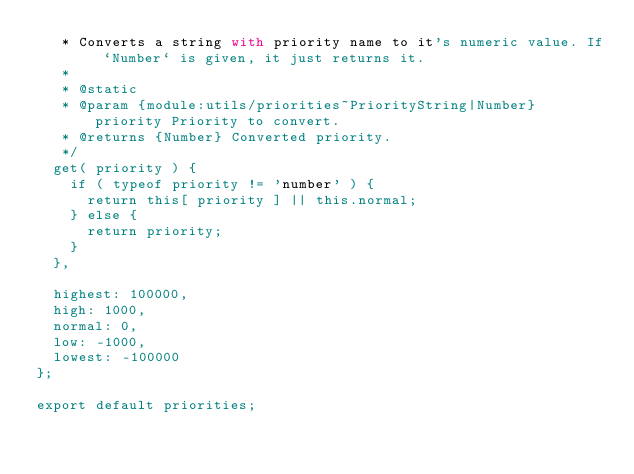Convert code to text. <code><loc_0><loc_0><loc_500><loc_500><_JavaScript_>	 * Converts a string with priority name to it's numeric value. If `Number` is given, it just returns it.
	 *
	 * @static
	 * @param {module:utils/priorities~PriorityString|Number} priority Priority to convert.
	 * @returns {Number} Converted priority.
	 */
	get( priority ) {
		if ( typeof priority != 'number' ) {
			return this[ priority ] || this.normal;
		} else {
			return priority;
		}
	},

	highest: 100000,
	high: 1000,
	normal: 0,
	low: -1000,
	lowest: -100000
};

export default priorities;
</code> 